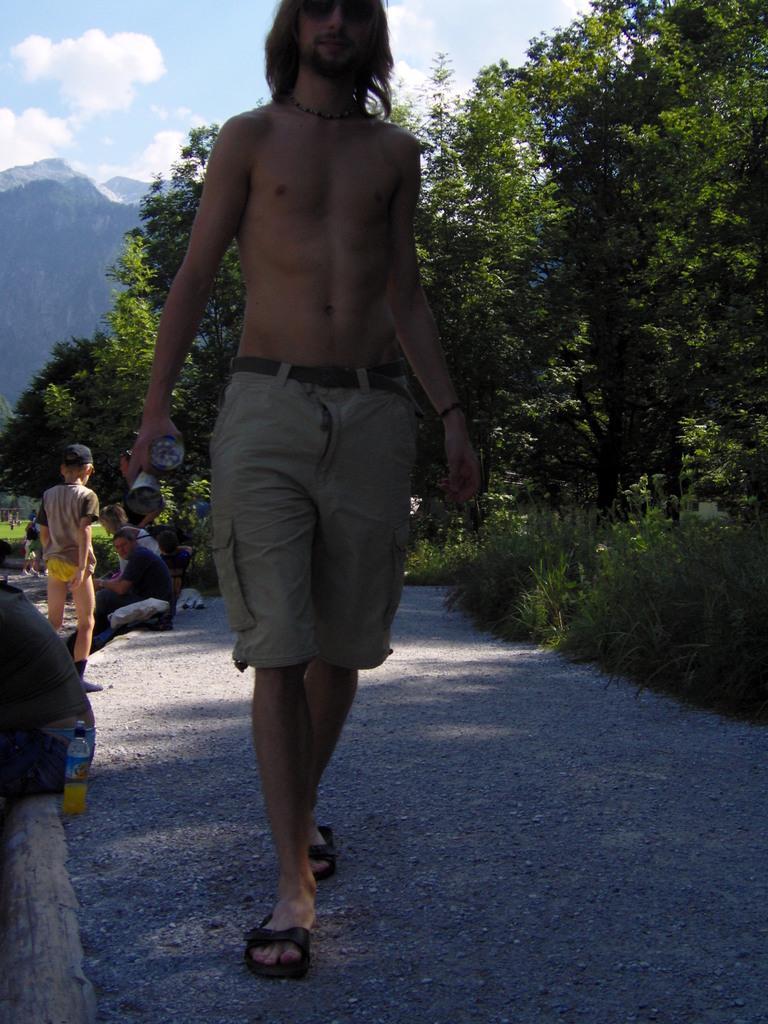Describe this image in one or two sentences. In this image I can see the group of people with the dresses. In the background I can see the trees, mountains, clouds and the sky. 